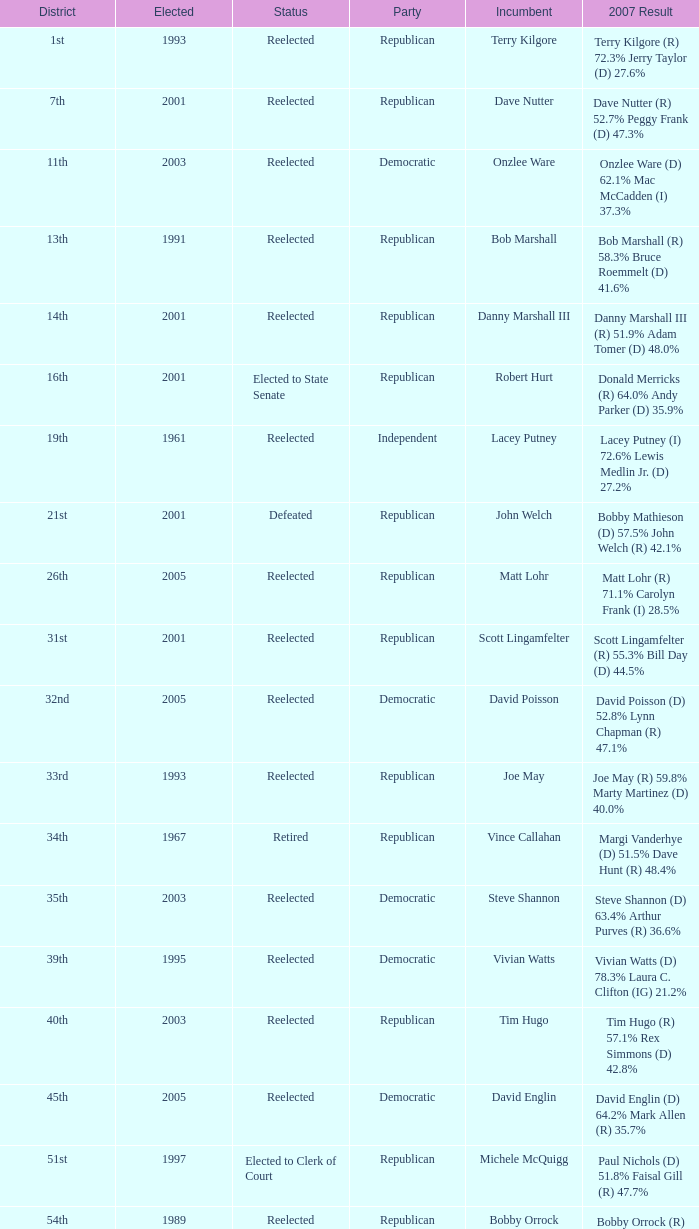What was the last year someone was elected to the 14th district? 2001.0. 